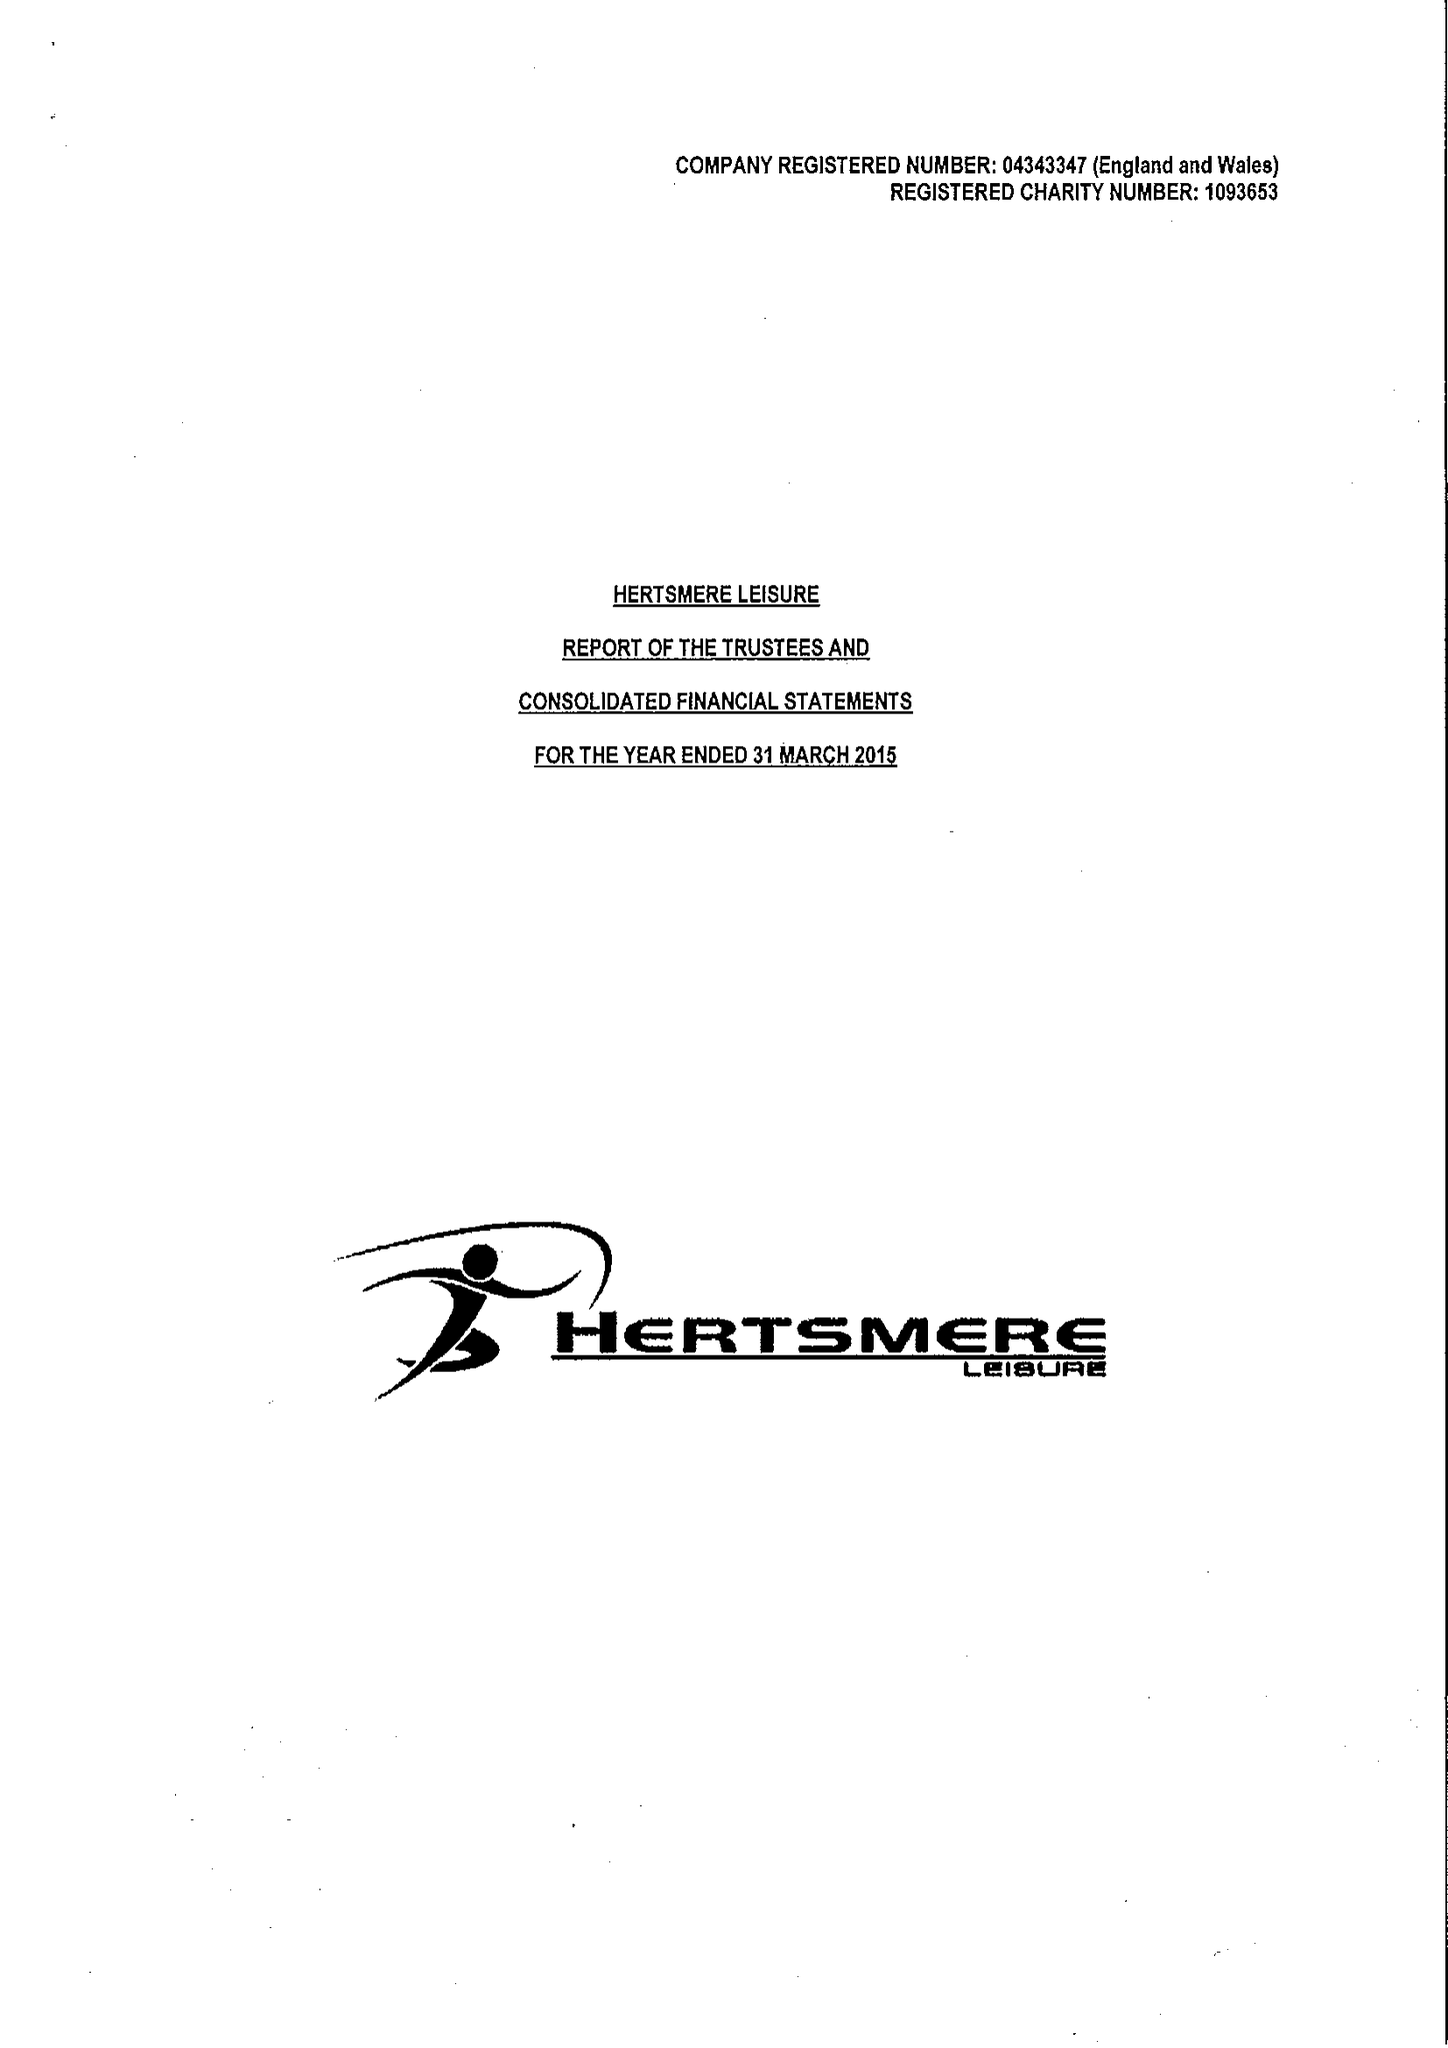What is the value for the address__post_town?
Answer the question using a single word or phrase. BOREHAMWOOD 